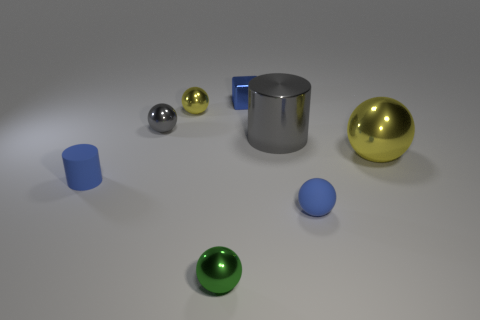There is a blue thing that is the same shape as the large gray metal thing; what is its material?
Offer a terse response. Rubber. What number of other objects are there of the same shape as the green metallic object?
Provide a short and direct response. 4. What number of large cylinders are in front of the green sphere in front of the blue thing right of the tiny blue shiny object?
Offer a very short reply. 0. How many tiny gray things are the same shape as the green object?
Your response must be concise. 1. There is a tiny metal thing right of the green metallic object; is it the same color as the matte cylinder?
Your answer should be compact. Yes. The small blue thing in front of the blue matte thing on the left side of the big gray metallic object that is in front of the tiny gray shiny thing is what shape?
Ensure brevity in your answer.  Sphere. Is the size of the metallic cube the same as the shiny ball to the right of the tiny blue sphere?
Your answer should be compact. No. Are there any yellow metal spheres that have the same size as the blue matte ball?
Give a very brief answer. Yes. What number of other things are made of the same material as the small green thing?
Ensure brevity in your answer.  5. What is the color of the tiny thing that is both on the left side of the tiny yellow object and right of the blue cylinder?
Offer a terse response. Gray. 